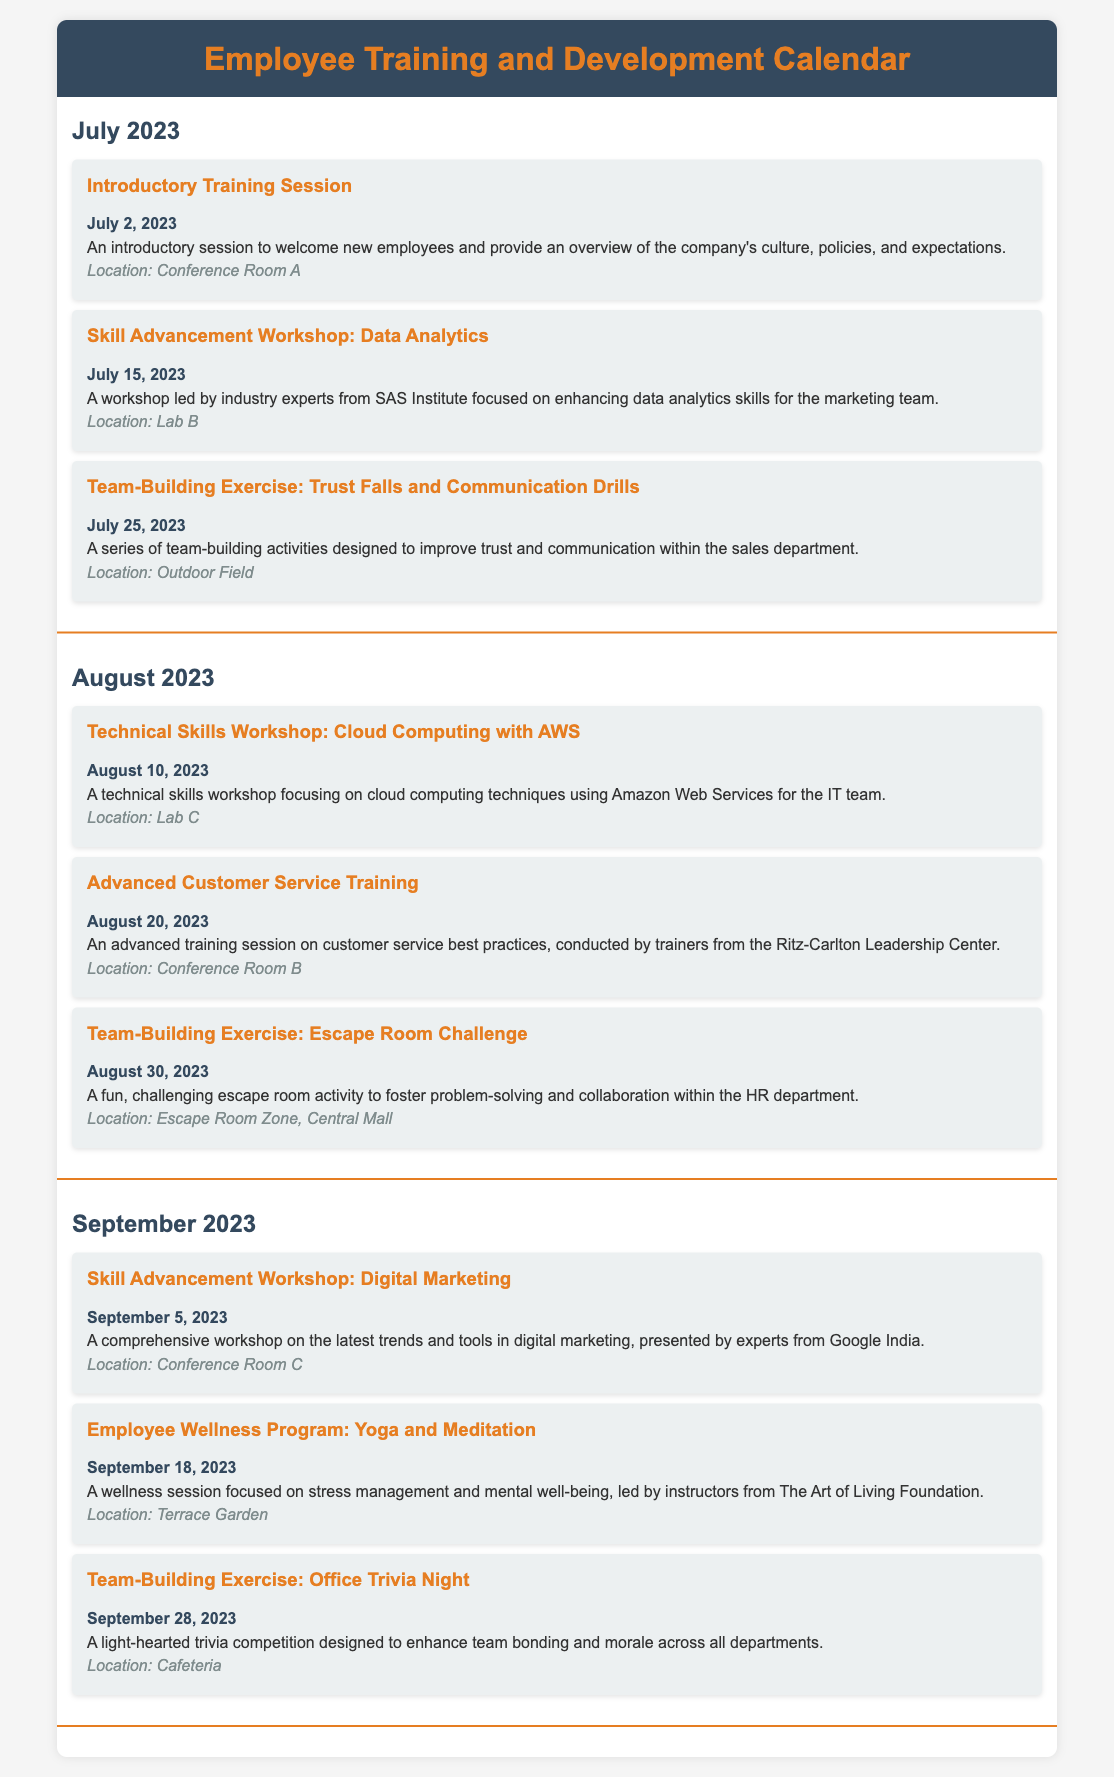what is the date of the Introductory Training Session? The date of the Introductory Training Session is specified in the document as July 2, 2023.
Answer: July 2, 2023 what is the location of the Skill Advancement Workshop: Data Analytics? The location for the Skill Advancement Workshop: Data Analytics is given as Lab B in the document.
Answer: Lab B which month has a Team-Building Exercise: Escape Room Challenge? The Team-Building Exercise: Escape Room Challenge is scheduled for August 2023, according to the document.
Answer: August who is conducting the Advanced Customer Service Training? The training session is conducted by trainers from the Ritz-Carlton Leadership Center, as mentioned in the document.
Answer: Ritz-Carlton Leadership Center how many events are scheduled in September 2023? The document lists three events scheduled in September 2023.
Answer: 3 what type of exercise is featured in the team-building activity on July 25, 2023? The team-building activity on July 25, 2023, features Trust Falls and Communication Drills, as described in the document.
Answer: Trust Falls and Communication Drills what is the focus of the Employee Wellness Program scheduled on September 18, 2023? The focus of the Employee Wellness Program is on stress management and mental well-being, as detailed in the document.
Answer: Stress management and mental well-being how many workshops are planned in total across the three months? There are five workshops planned in total across July, August, and September 2023, based on the document's content.
Answer: 5 when is the Yoga and Meditation session scheduled? The Yoga and Meditation session is scheduled for September 18, 2023, as indicated in the document.
Answer: September 18, 2023 